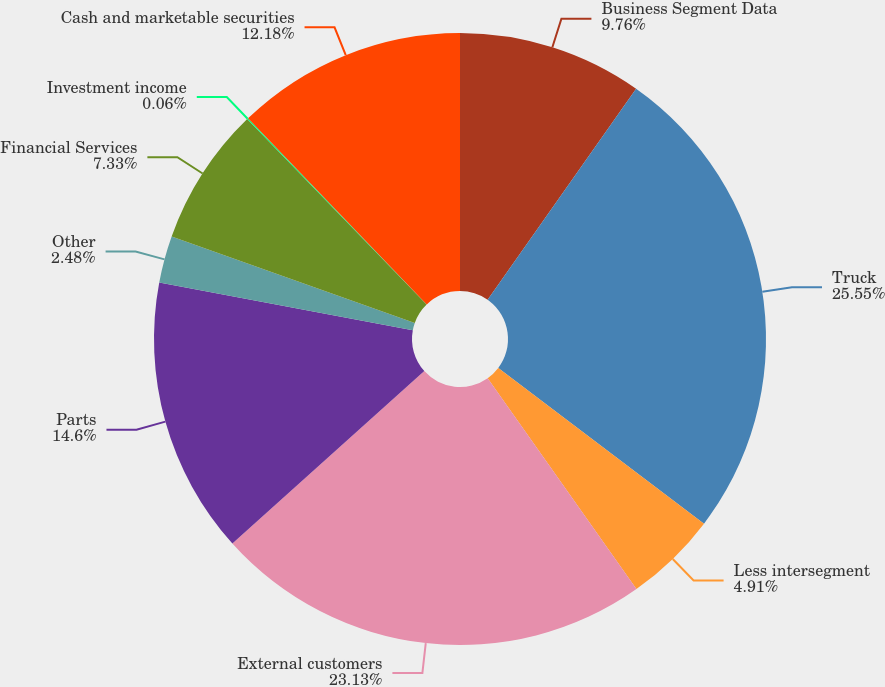Convert chart. <chart><loc_0><loc_0><loc_500><loc_500><pie_chart><fcel>Business Segment Data<fcel>Truck<fcel>Less intersegment<fcel>External customers<fcel>Parts<fcel>Other<fcel>Financial Services<fcel>Investment income<fcel>Cash and marketable securities<nl><fcel>9.76%<fcel>25.55%<fcel>4.91%<fcel>23.13%<fcel>14.6%<fcel>2.48%<fcel>7.33%<fcel>0.06%<fcel>12.18%<nl></chart> 